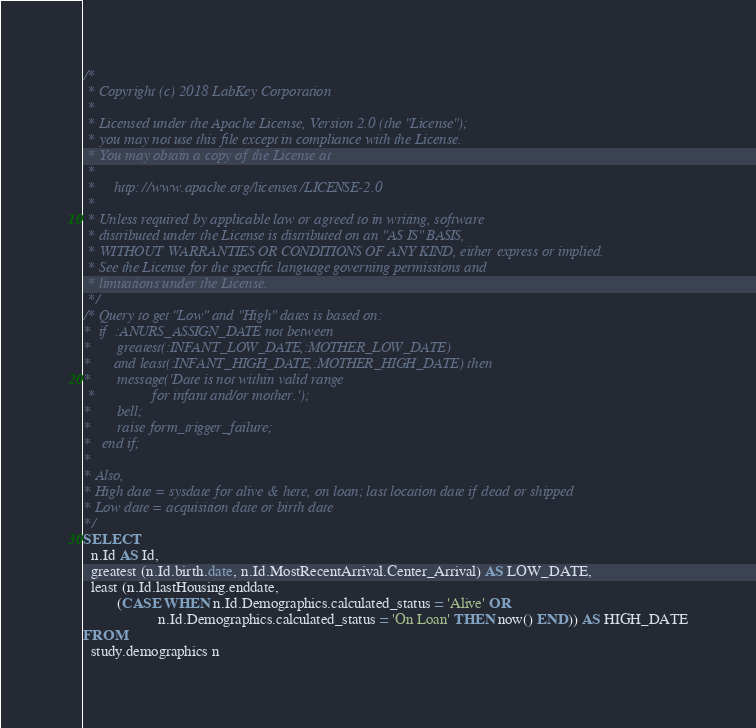Convert code to text. <code><loc_0><loc_0><loc_500><loc_500><_SQL_>/*
 * Copyright (c) 2018 LabKey Corporation
 *
 * Licensed under the Apache License, Version 2.0 (the "License");
 * you may not use this file except in compliance with the License.
 * You may obtain a copy of the License at
 *
 *     http://www.apache.org/licenses/LICENSE-2.0
 *
 * Unless required by applicable law or agreed to in writing, software
 * distributed under the License is distributed on an "AS IS" BASIS,
 * WITHOUT WARRANTIES OR CONDITIONS OF ANY KIND, either express or implied.
 * See the License for the specific language governing permissions and
 * limitations under the License.
 */
/* Query to get "Low" and "High" dates is based on:
*  if  :ANURS_ASSIGN_DATE not between
*       greatest(:INFANT_LOW_DATE,:MOTHER_LOW_DATE)
*      and least(:INFANT_HIGH_DATE,:MOTHER_HIGH_DATE) then
*       message('Date is not within valid range
 *               for infant and/or mother.');
*       bell;
*       raise form_trigger_failure;
*   end if;
*
* Also,
* High date = sysdate for alive & here, on loan; last location date if dead or shipped
* Low date = acquisition date or birth date
*/
SELECT
  n.Id AS Id,
  greatest (n.Id.birth.date, n.Id.MostRecentArrival.Center_Arrival) AS LOW_DATE,
  least (n.Id.lastHousing.enddate,
         (CASE WHEN n.Id.Demographics.calculated_status = 'Alive' OR
                    n.Id.Demographics.calculated_status = 'On Loan' THEN now() END)) AS HIGH_DATE
FROM
  study.demographics n</code> 